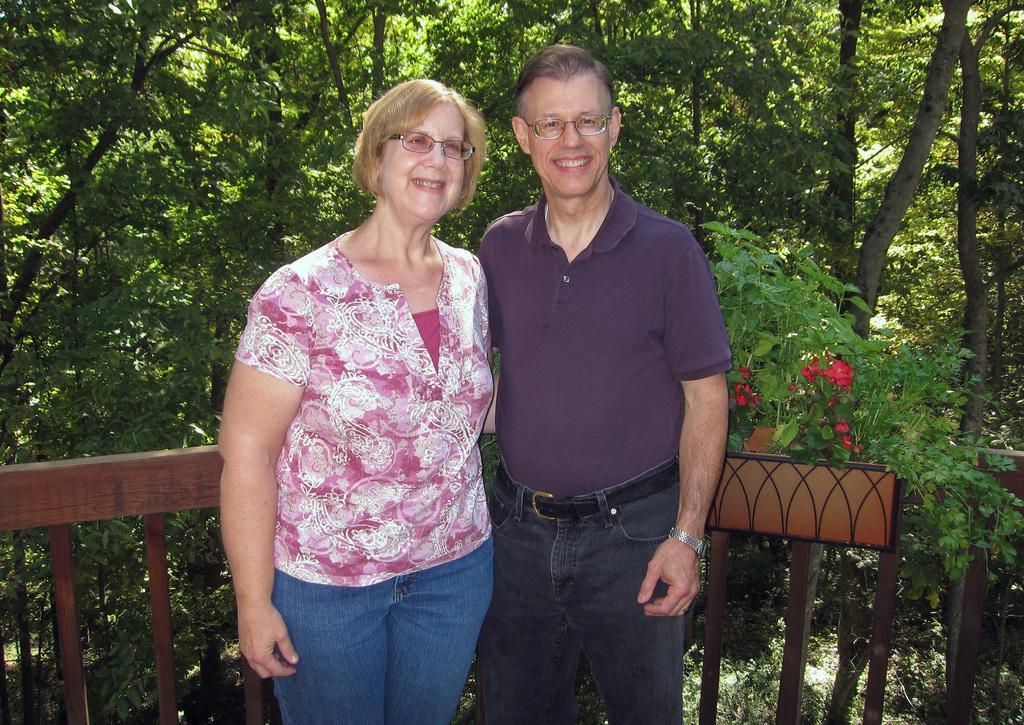Please provide a concise description of this image. In this picture I can observe a couple. Both of them are smiling and wearing spectacles. Man is wearing purple color T shirt. Behind them there is a railing. In the background there are trees. 